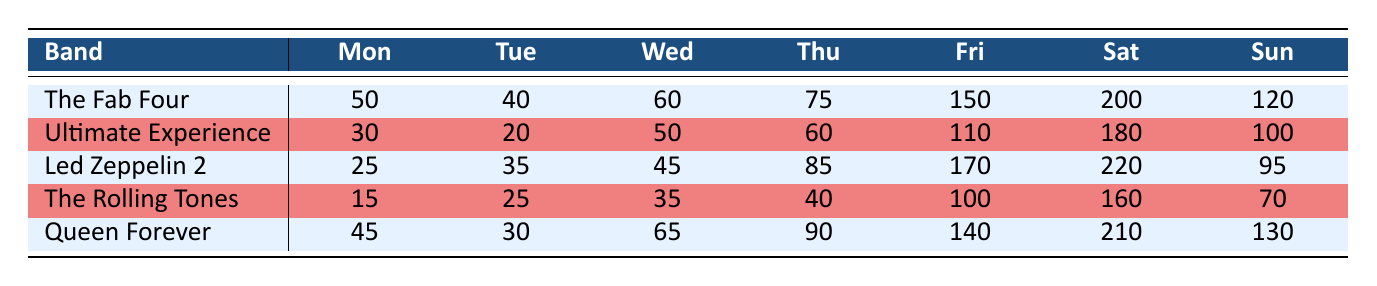What tribute band had the highest ticket sales on Saturday? By examining the sales for each band on Saturday, we can see that Led Zeppelin 2 has the highest number with 220.
Answer: Led Zeppelin 2 What is the total ticket sales for The Fab Four across all days? To find the total, we add the daily ticket sales: 50 + 40 + 60 + 75 + 150 + 200 + 120 = 695.
Answer: 695 Did Ultimate Experience sell more tickets on Friday than The Rolling Tones? On Friday, Ultimate Experience sold 110 tickets, while The Rolling Tones sold 100 tickets. Since 110 is greater than 100, the answer is yes.
Answer: Yes What is the average ticket sales for Queen Forever on weekdays (Monday to Friday)? We sum the ticket sales for Queen Forever on weekdays: 45 + 30 + 65 + 90 + 140 = 370. Then, we divide by the number of weekdays (5): 370 / 5 = 74.
Answer: 74 Which band had the lowest total ticket sales on Sunday? For Sunday, we check each band's sales: The Fab Four - 120, Ultimate Experience - 100, Led Zeppelin 2 - 95, The Rolling Tones - 70, Queen Forever - 130. The lowest is The Rolling Tones with 70.
Answer: The Rolling Tones What was the difference in ticket sales for The Fab Four between the highest and lowest days? The highest sales for The Fab Four was on Saturday with 200 tickets, and the lowest was on Tuesday with 40 tickets. The difference is 200 - 40 = 160.
Answer: 160 How many tickets did all bands sell combined on Wednesdays? Adding the sales for all bands on Wednesday: 60 + 50 + 45 + 35 + 65 = 255.
Answer: 255 Is the total ticket sales for Fridays across all bands higher than for Mondays? Total for Fridays: 150 + 110 + 170 + 100 + 140 = 670. Total for Mondays: 50 + 30 + 25 + 15 + 45 = 165. Since 670 is greater than 165, the answer is yes.
Answer: Yes 